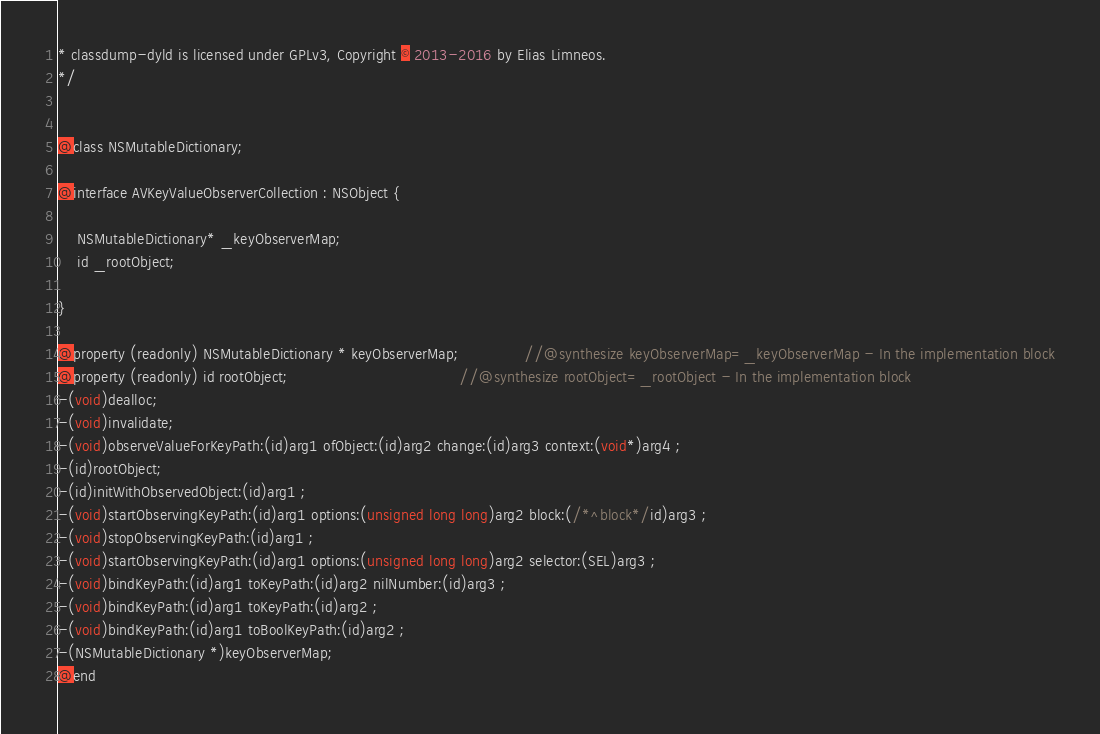Convert code to text. <code><loc_0><loc_0><loc_500><loc_500><_C_>* classdump-dyld is licensed under GPLv3, Copyright © 2013-2016 by Elias Limneos.
*/


@class NSMutableDictionary;

@interface AVKeyValueObserverCollection : NSObject {

	NSMutableDictionary* _keyObserverMap;
	id _rootObject;

}

@property (readonly) NSMutableDictionary * keyObserverMap;              //@synthesize keyObserverMap=_keyObserverMap - In the implementation block
@property (readonly) id rootObject;                                     //@synthesize rootObject=_rootObject - In the implementation block
-(void)dealloc;
-(void)invalidate;
-(void)observeValueForKeyPath:(id)arg1 ofObject:(id)arg2 change:(id)arg3 context:(void*)arg4 ;
-(id)rootObject;
-(id)initWithObservedObject:(id)arg1 ;
-(void)startObservingKeyPath:(id)arg1 options:(unsigned long long)arg2 block:(/*^block*/id)arg3 ;
-(void)stopObservingKeyPath:(id)arg1 ;
-(void)startObservingKeyPath:(id)arg1 options:(unsigned long long)arg2 selector:(SEL)arg3 ;
-(void)bindKeyPath:(id)arg1 toKeyPath:(id)arg2 nilNumber:(id)arg3 ;
-(void)bindKeyPath:(id)arg1 toKeyPath:(id)arg2 ;
-(void)bindKeyPath:(id)arg1 toBoolKeyPath:(id)arg2 ;
-(NSMutableDictionary *)keyObserverMap;
@end

</code> 